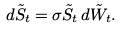<formula> <loc_0><loc_0><loc_500><loc_500>d { \tilde { S } } _ { t } = \sigma { \tilde { S } } _ { t } \, d { \tilde { W } } _ { t } .</formula> 